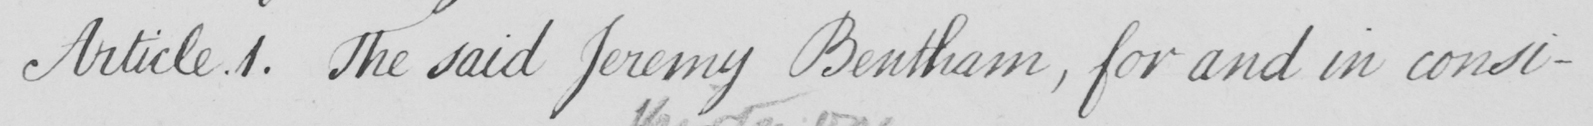Please transcribe the handwritten text in this image. Article.1 . The said Jeremy Bentham , for and in consi- 